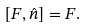<formula> <loc_0><loc_0><loc_500><loc_500>[ F , \hat { n } ] = F .</formula> 